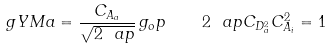<formula> <loc_0><loc_0><loc_500><loc_500>\ g Y M { a } = \frac { C _ { A _ { a } } } { \sqrt { 2 \ a p } } \, g _ { o } p \quad 2 \ a p C _ { D ^ { 2 } _ { a } } C _ { A _ { i } } ^ { 2 } = 1</formula> 